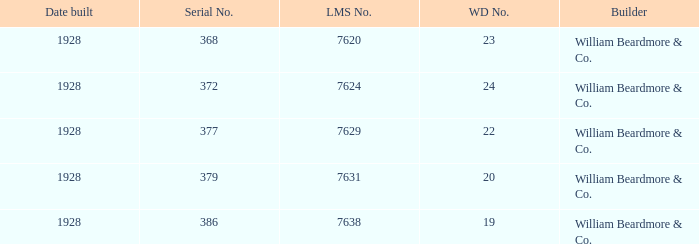Could you help me parse every detail presented in this table? {'header': ['Date built', 'Serial No.', 'LMS No.', 'WD No.', 'Builder'], 'rows': [['1928', '368', '7620', '23', 'William Beardmore & Co.'], ['1928', '372', '7624', '24', 'William Beardmore & Co.'], ['1928', '377', '7629', '22', 'William Beardmore & Co.'], ['1928', '379', '7631', '20', 'William Beardmore & Co.'], ['1928', '386', '7638', '19', 'William Beardmore & Co.']]} Name the builder for serial number being 377 William Beardmore & Co. 